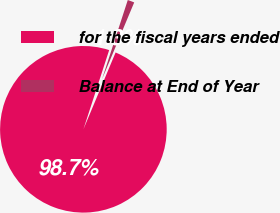<chart> <loc_0><loc_0><loc_500><loc_500><pie_chart><fcel>for the fiscal years ended<fcel>Balance at End of Year<nl><fcel>98.69%<fcel>1.31%<nl></chart> 